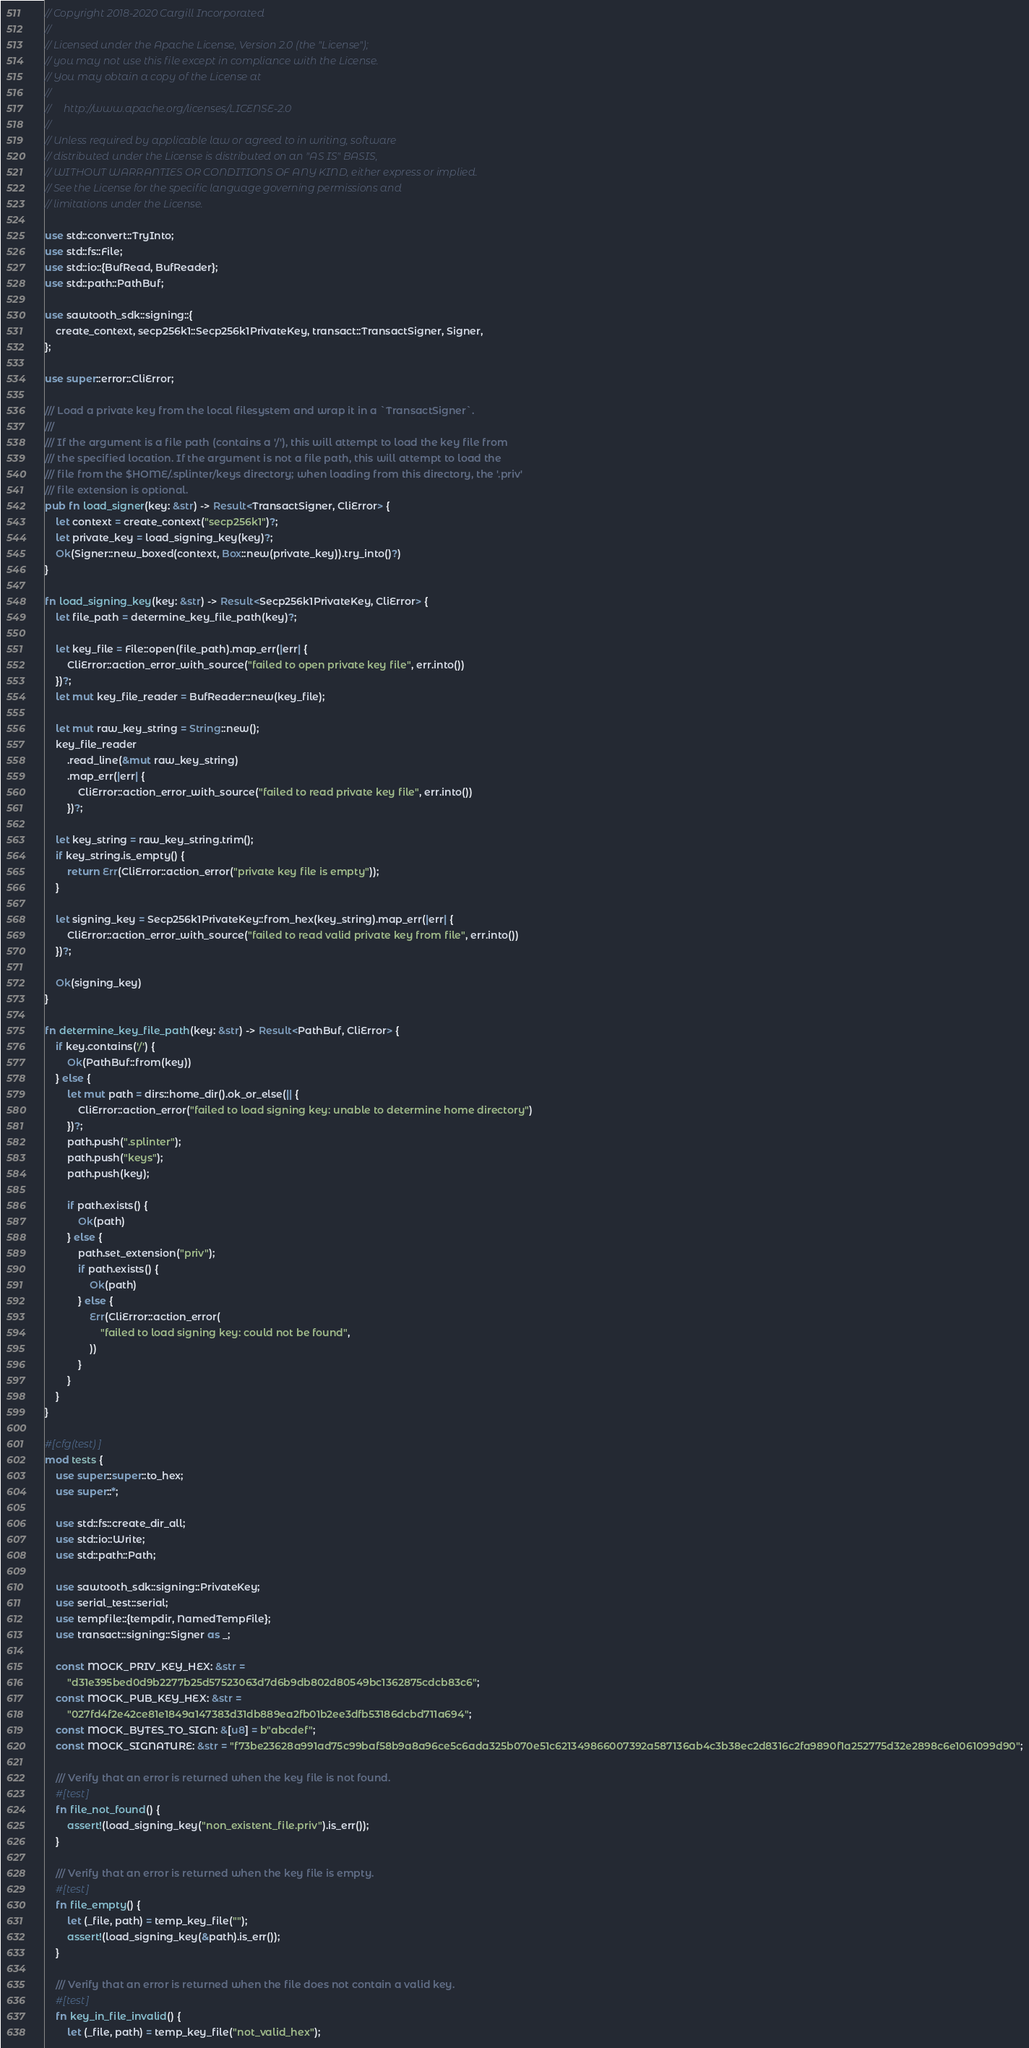<code> <loc_0><loc_0><loc_500><loc_500><_Rust_>// Copyright 2018-2020 Cargill Incorporated
//
// Licensed under the Apache License, Version 2.0 (the "License");
// you may not use this file except in compliance with the License.
// You may obtain a copy of the License at
//
//     http://www.apache.org/licenses/LICENSE-2.0
//
// Unless required by applicable law or agreed to in writing, software
// distributed under the License is distributed on an "AS IS" BASIS,
// WITHOUT WARRANTIES OR CONDITIONS OF ANY KIND, either express or implied.
// See the License for the specific language governing permissions and
// limitations under the License.

use std::convert::TryInto;
use std::fs::File;
use std::io::{BufRead, BufReader};
use std::path::PathBuf;

use sawtooth_sdk::signing::{
    create_context, secp256k1::Secp256k1PrivateKey, transact::TransactSigner, Signer,
};

use super::error::CliError;

/// Load a private key from the local filesystem and wrap it in a `TransactSigner`.
///
/// If the argument is a file path (contains a '/'), this will attempt to load the key file from
/// the specified location. If the argument is not a file path, this will attempt to load the
/// file from the $HOME/.splinter/keys directory; when loading from this directory, the '.priv'
/// file extension is optional.
pub fn load_signer(key: &str) -> Result<TransactSigner, CliError> {
    let context = create_context("secp256k1")?;
    let private_key = load_signing_key(key)?;
    Ok(Signer::new_boxed(context, Box::new(private_key)).try_into()?)
}

fn load_signing_key(key: &str) -> Result<Secp256k1PrivateKey, CliError> {
    let file_path = determine_key_file_path(key)?;

    let key_file = File::open(file_path).map_err(|err| {
        CliError::action_error_with_source("failed to open private key file", err.into())
    })?;
    let mut key_file_reader = BufReader::new(key_file);

    let mut raw_key_string = String::new();
    key_file_reader
        .read_line(&mut raw_key_string)
        .map_err(|err| {
            CliError::action_error_with_source("failed to read private key file", err.into())
        })?;

    let key_string = raw_key_string.trim();
    if key_string.is_empty() {
        return Err(CliError::action_error("private key file is empty"));
    }

    let signing_key = Secp256k1PrivateKey::from_hex(key_string).map_err(|err| {
        CliError::action_error_with_source("failed to read valid private key from file", err.into())
    })?;

    Ok(signing_key)
}

fn determine_key_file_path(key: &str) -> Result<PathBuf, CliError> {
    if key.contains('/') {
        Ok(PathBuf::from(key))
    } else {
        let mut path = dirs::home_dir().ok_or_else(|| {
            CliError::action_error("failed to load signing key: unable to determine home directory")
        })?;
        path.push(".splinter");
        path.push("keys");
        path.push(key);

        if path.exists() {
            Ok(path)
        } else {
            path.set_extension("priv");
            if path.exists() {
                Ok(path)
            } else {
                Err(CliError::action_error(
                    "failed to load signing key: could not be found",
                ))
            }
        }
    }
}

#[cfg(test)]
mod tests {
    use super::super::to_hex;
    use super::*;

    use std::fs::create_dir_all;
    use std::io::Write;
    use std::path::Path;

    use sawtooth_sdk::signing::PrivateKey;
    use serial_test::serial;
    use tempfile::{tempdir, NamedTempFile};
    use transact::signing::Signer as _;

    const MOCK_PRIV_KEY_HEX: &str =
        "d31e395bed0d9b2277b25d57523063d7d6b9db802d80549bc1362875cdcb83c6";
    const MOCK_PUB_KEY_HEX: &str =
        "027fd4f2e42ce81e1849a147383d31db889ea2fb01b2ee3dfb53186dcbd711a694";
    const MOCK_BYTES_TO_SIGN: &[u8] = b"abcdef";
    const MOCK_SIGNATURE: &str = "f73be23628a991ad75c99baf58b9a8a96ce5c6ada325b070e51c621349866007392a587136ab4c3b38ec2d8316c2fa9890f1a252775d32e2898c6e1061099d90";

    /// Verify that an error is returned when the key file is not found.
    #[test]
    fn file_not_found() {
        assert!(load_signing_key("non_existent_file.priv").is_err());
    }

    /// Verify that an error is returned when the key file is empty.
    #[test]
    fn file_empty() {
        let (_file, path) = temp_key_file("");
        assert!(load_signing_key(&path).is_err());
    }

    /// Verify that an error is returned when the file does not contain a valid key.
    #[test]
    fn key_in_file_invalid() {
        let (_file, path) = temp_key_file("not_valid_hex");</code> 